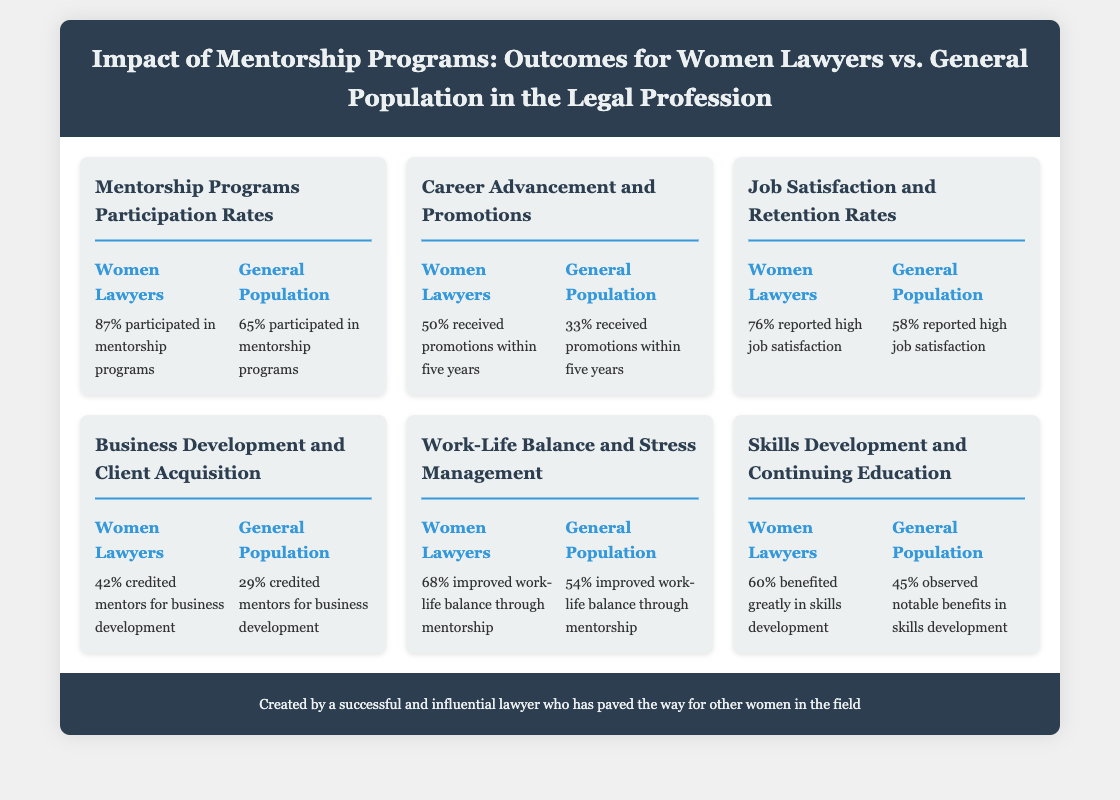What percentage of women lawyers participated in mentorship programs? The document states that 87% of women lawyers participated in mentorship programs.
Answer: 87% What percentage of the general population participated in mentorship programs? According to the document, 65% of the general population participated in mentorship programs.
Answer: 65% What percentage of women lawyers received promotions within five years? The document indicates that 50% of women lawyers received promotions within five years.
Answer: 50% What percentage of the general population received promotions within five years? The document shows that 33% of the general population received promotions within five years.
Answer: 33% Which group had a higher rate of reporting high job satisfaction? The document reveals that 76% of women lawyers reported high job satisfaction compared to 58% of the general population.
Answer: Women Lawyers What percentage of women lawyers credited mentors for business development? According to the document, 42% of women lawyers credited mentors for business development.
Answer: 42% What was the percentage of the general population that credited mentors for business development? The document states that 29% of the general population credited mentors for business development.
Answer: 29% Which group had a better improvement in work-life balance through mentorship? The document indicates that 68% of women lawyers improved work-life balance through mentorship compared to 54% of the general population.
Answer: Women Lawyers What percentage of women lawyers benefited greatly in skills development? The document states that 60% of women lawyers benefited greatly in skills development.
Answer: 60% What percentage of the general population observed notable benefits in skills development? The document indicates that 45% of the general population observed notable benefits in skills development.
Answer: 45% 